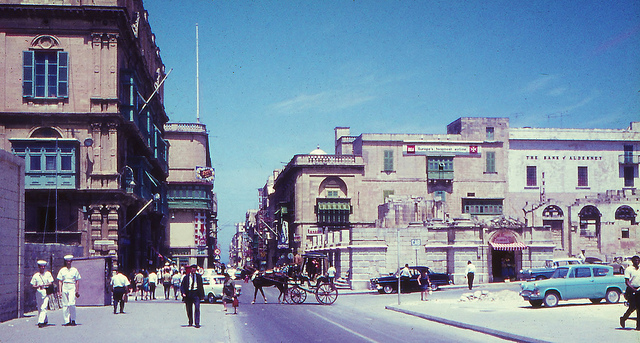<image>How many people are there? It is unanswerable how many people are there. The number can vary from 2 dozen to 30. How many people are there? There is no definite answer to how many people are there. It can be seen as '2 dozen', '20', '30', '17' or '15'. 